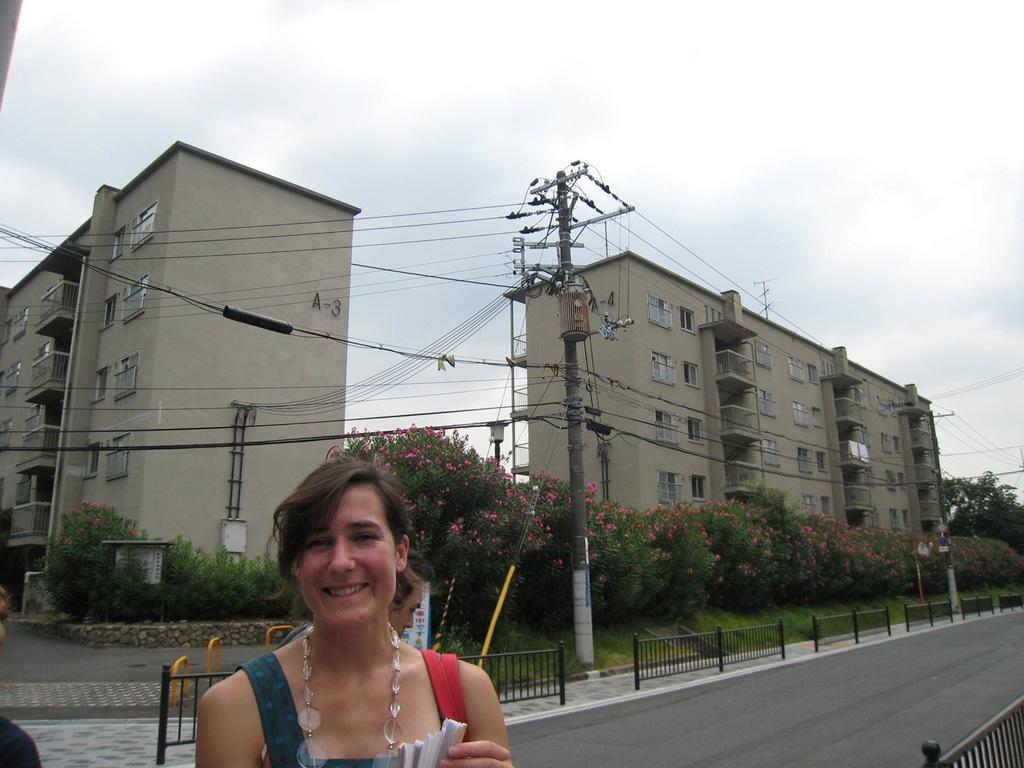In one or two sentences, can you explain what this image depicts? This picture is clicked outside the city. In this picture, we see a woman is standing and she is smiling. Behind her, we see a man is standing. At the bottom, we see the road. On either side of the picture, we see the road railing. Beside that, we see an electric pole and the wires. There are trees which have flowers and these flowers are in pink color. There are trees, buildings and the poles in the background. At the top, we see the sky. 